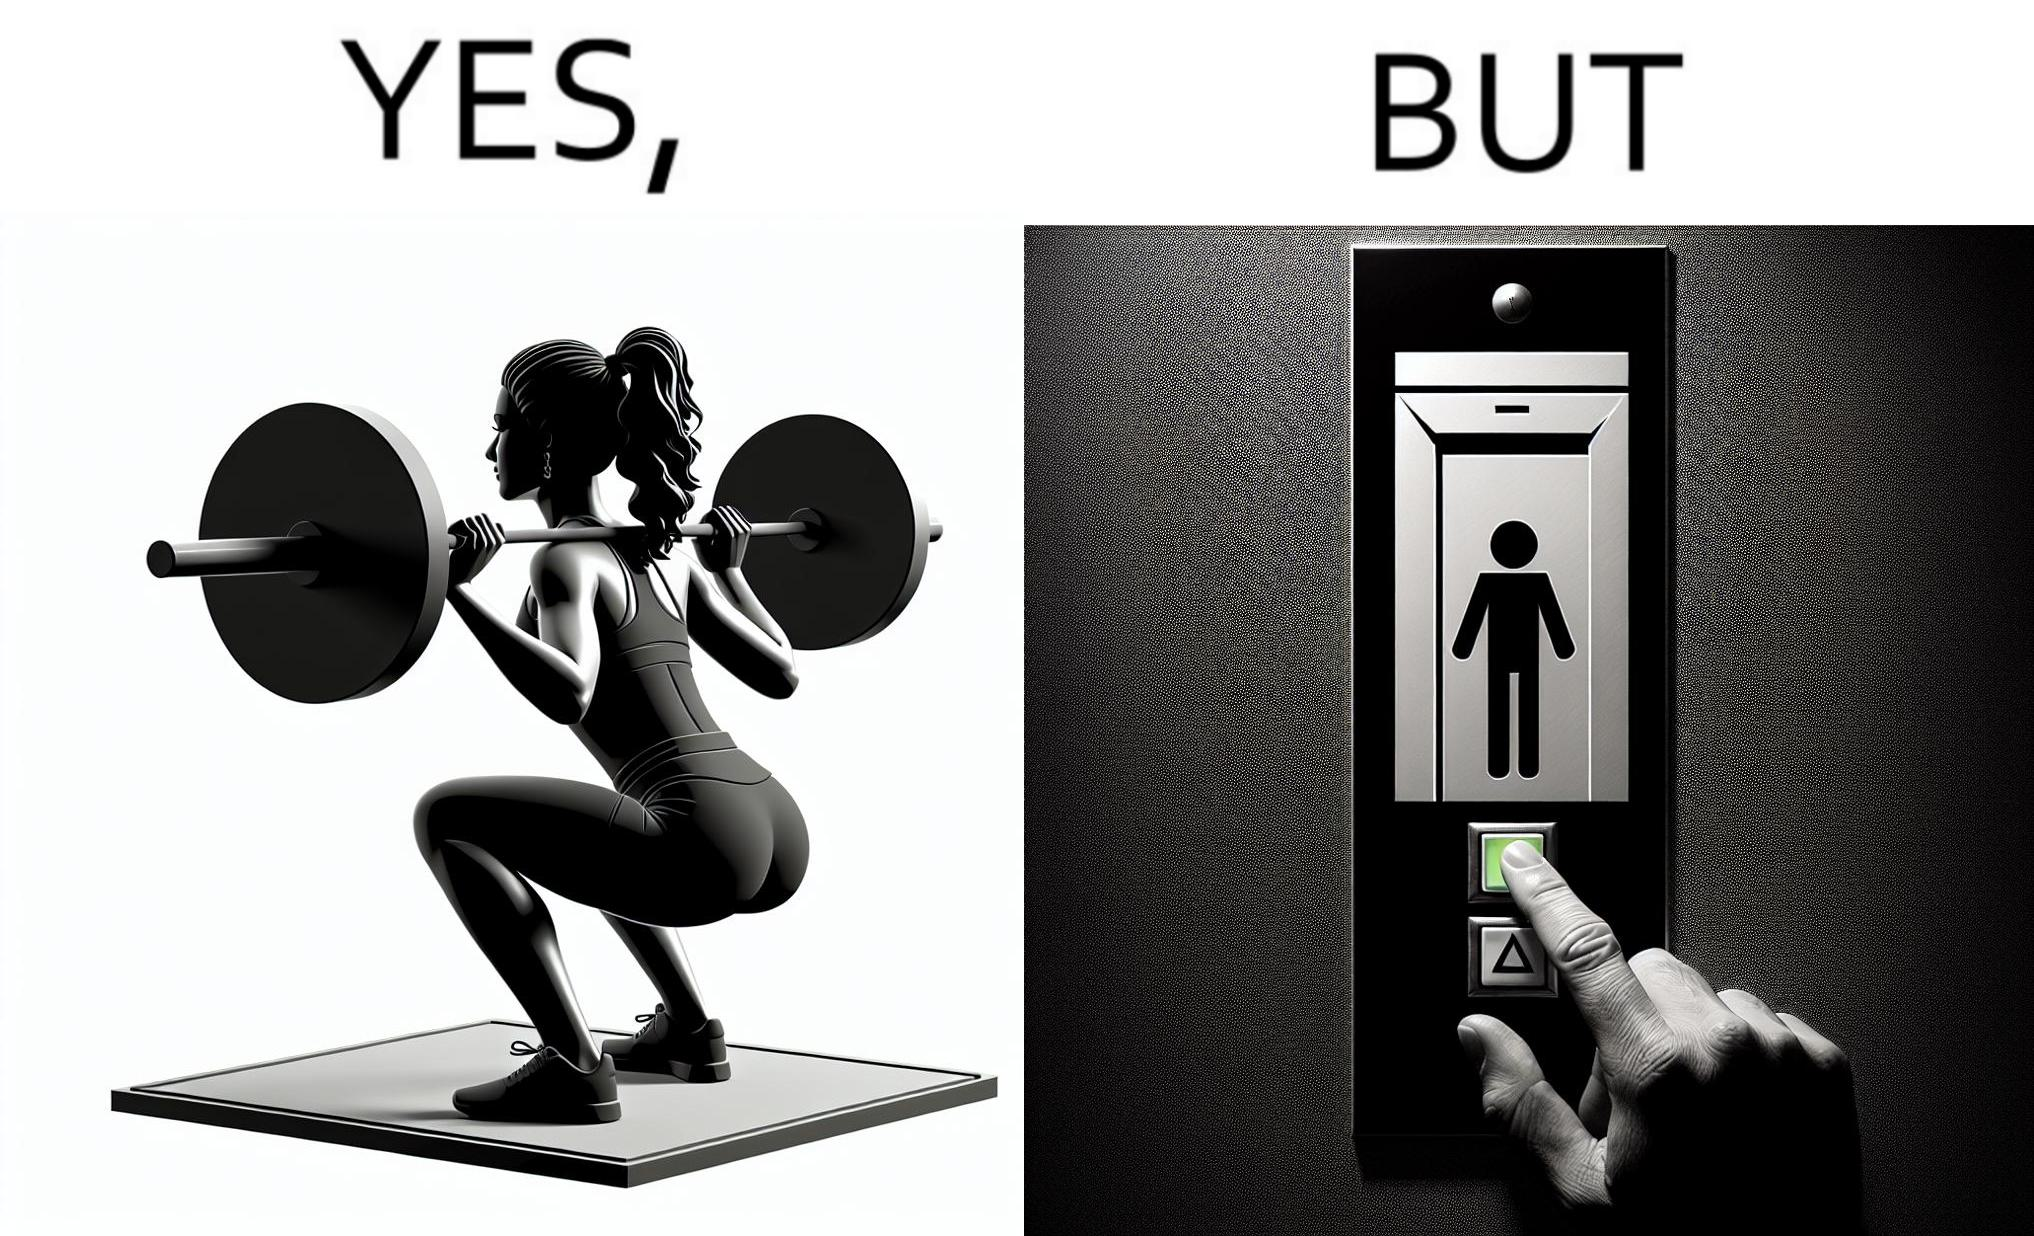Provide a description of this image. The image is satirical because it shows that while people do various kinds of exercises and go to gym to stay fit, they avoid doing simplest of physical tasks like using stairs instead of elevators to get to even the first or the second floor of a building. 